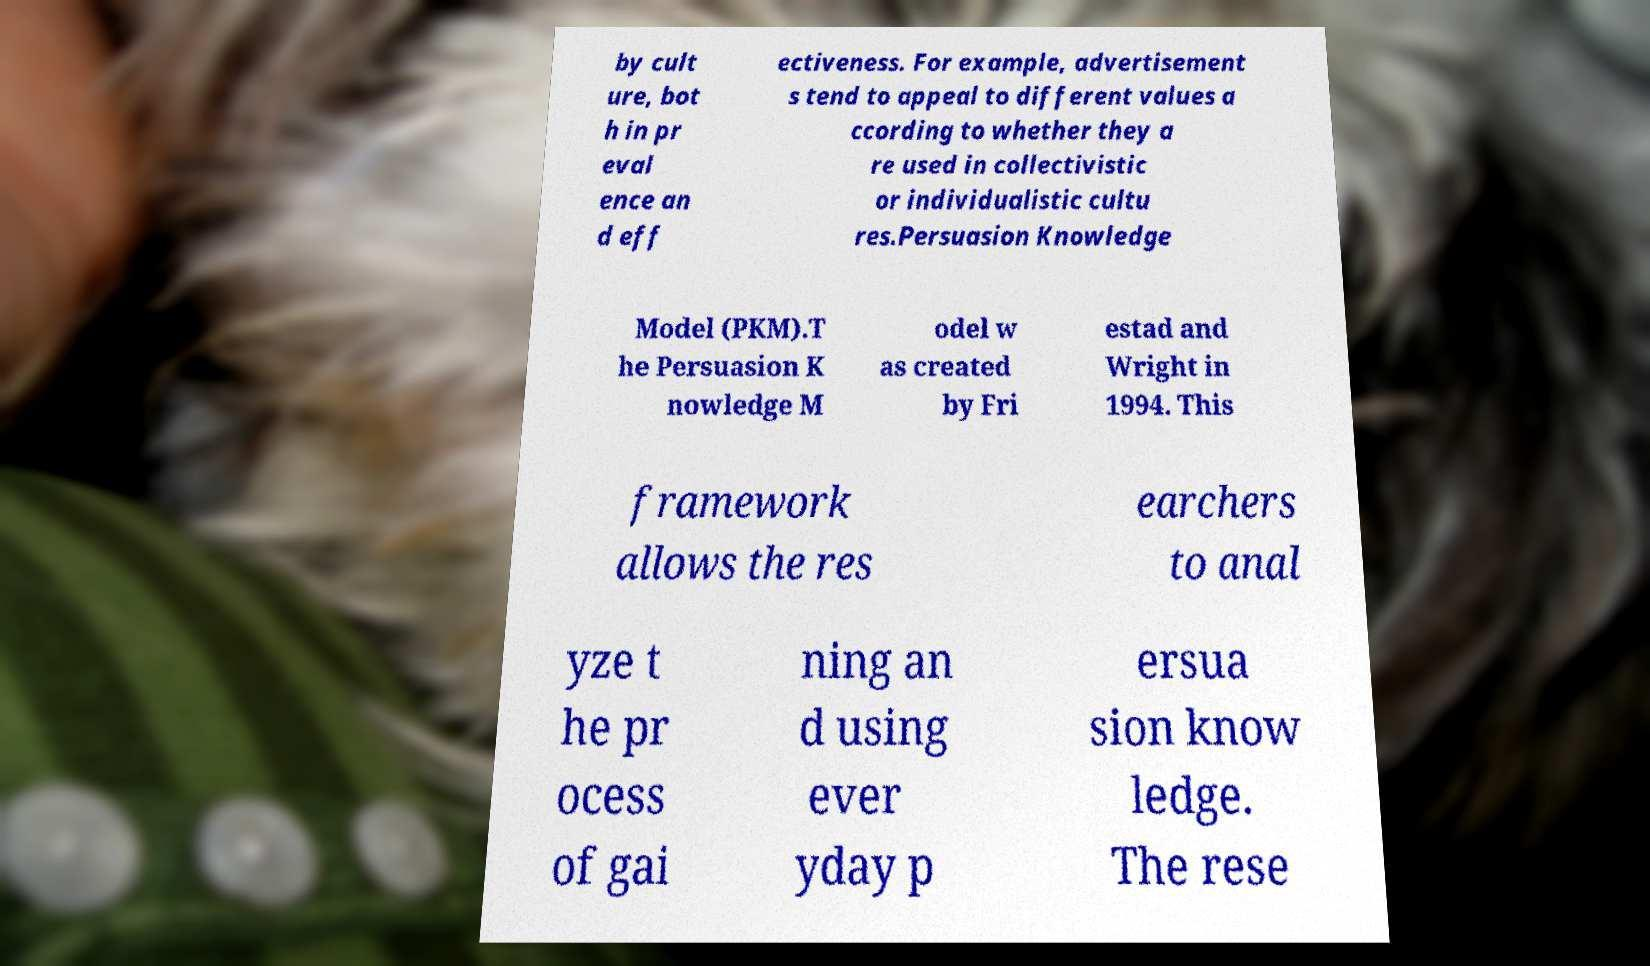Could you extract and type out the text from this image? by cult ure, bot h in pr eval ence an d eff ectiveness. For example, advertisement s tend to appeal to different values a ccording to whether they a re used in collectivistic or individualistic cultu res.Persuasion Knowledge Model (PKM).T he Persuasion K nowledge M odel w as created by Fri estad and Wright in 1994. This framework allows the res earchers to anal yze t he pr ocess of gai ning an d using ever yday p ersua sion know ledge. The rese 